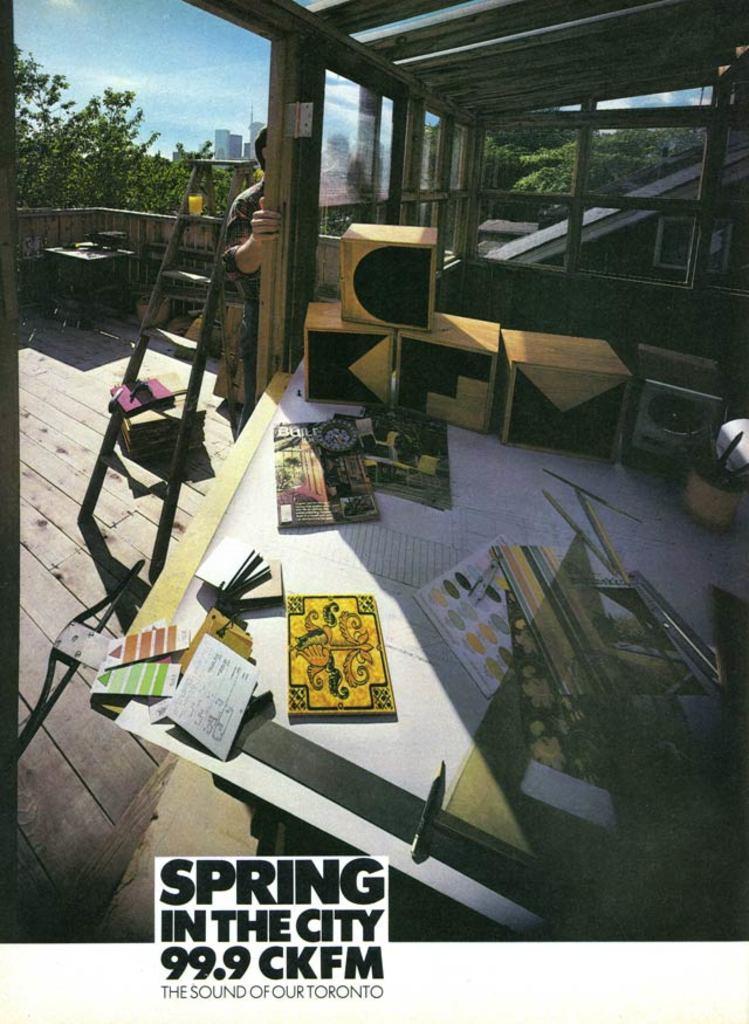Please provide a concise description of this image. In this image we can see a house. In the house there are few objects on a table and there is a person standing. Beside the person we can see a ladder. Behind the house there are group of trees and buildings. In the top left, we can see the sky. At the bottom we can see the text. 